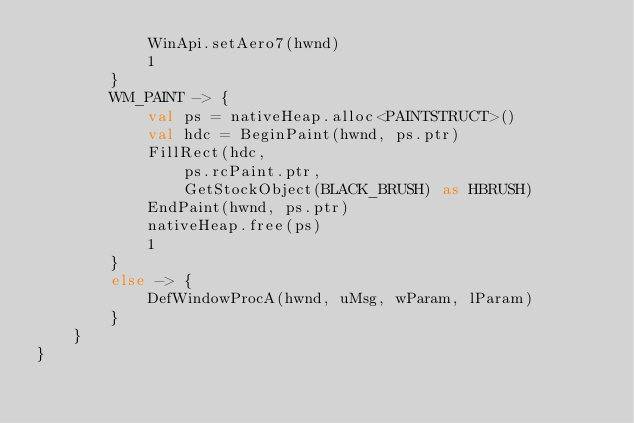<code> <loc_0><loc_0><loc_500><loc_500><_Kotlin_>            WinApi.setAero7(hwnd)
            1
        }
        WM_PAINT -> {
            val ps = nativeHeap.alloc<PAINTSTRUCT>()
            val hdc = BeginPaint(hwnd, ps.ptr)
            FillRect(hdc,
                ps.rcPaint.ptr,
                GetStockObject(BLACK_BRUSH) as HBRUSH)
            EndPaint(hwnd, ps.ptr)
            nativeHeap.free(ps)
            1
        }
        else -> {
            DefWindowProcA(hwnd, uMsg, wParam, lParam)
        }
    }
}</code> 